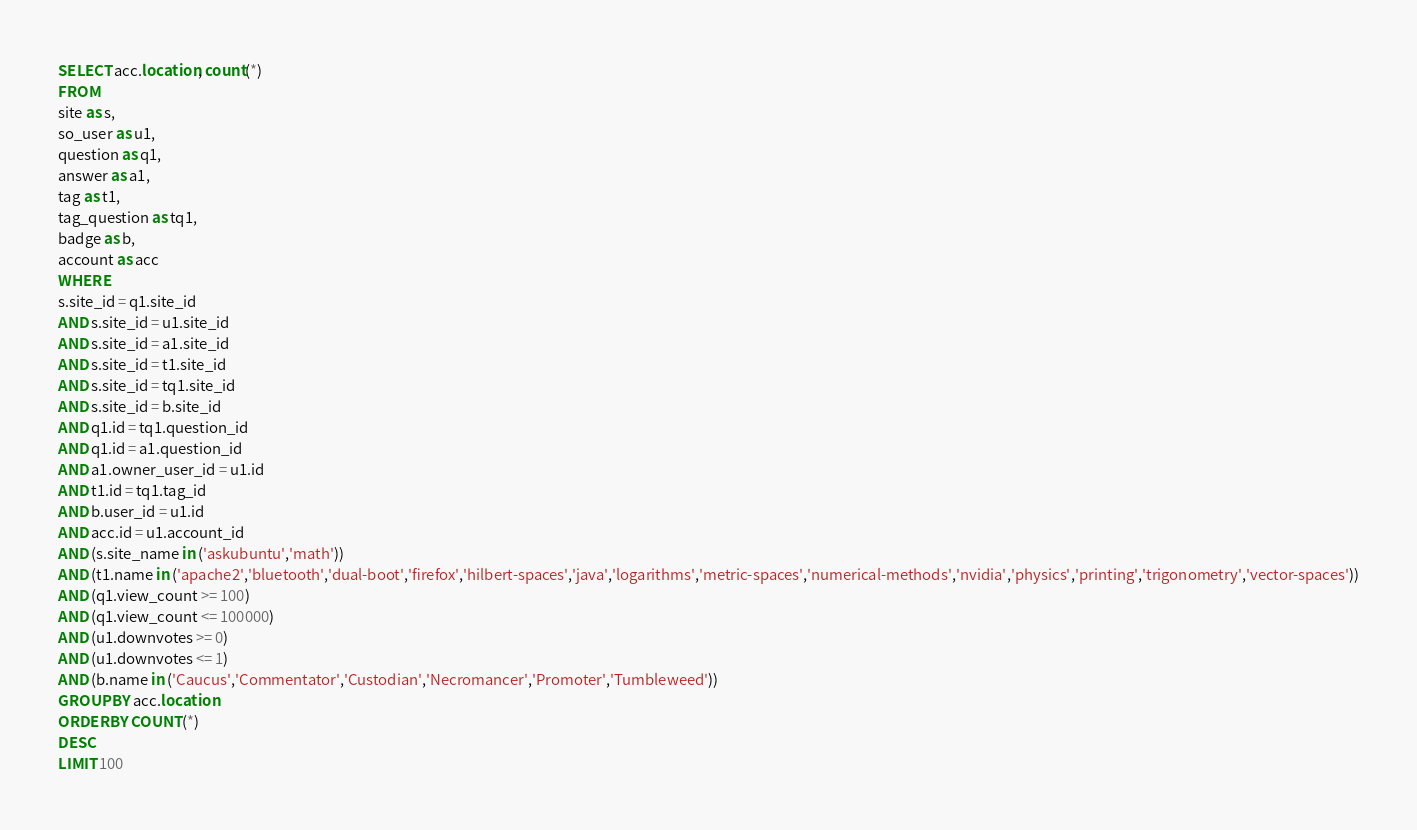<code> <loc_0><loc_0><loc_500><loc_500><_SQL_>SELECT acc.location, count(*)
FROM
site as s,
so_user as u1,
question as q1,
answer as a1,
tag as t1,
tag_question as tq1,
badge as b,
account as acc
WHERE
s.site_id = q1.site_id
AND s.site_id = u1.site_id
AND s.site_id = a1.site_id
AND s.site_id = t1.site_id
AND s.site_id = tq1.site_id
AND s.site_id = b.site_id
AND q1.id = tq1.question_id
AND q1.id = a1.question_id
AND a1.owner_user_id = u1.id
AND t1.id = tq1.tag_id
AND b.user_id = u1.id
AND acc.id = u1.account_id
AND (s.site_name in ('askubuntu','math'))
AND (t1.name in ('apache2','bluetooth','dual-boot','firefox','hilbert-spaces','java','logarithms','metric-spaces','numerical-methods','nvidia','physics','printing','trigonometry','vector-spaces'))
AND (q1.view_count >= 100)
AND (q1.view_count <= 100000)
AND (u1.downvotes >= 0)
AND (u1.downvotes <= 1)
AND (b.name in ('Caucus','Commentator','Custodian','Necromancer','Promoter','Tumbleweed'))
GROUP BY acc.location
ORDER BY COUNT(*)
DESC
LIMIT 100
</code> 